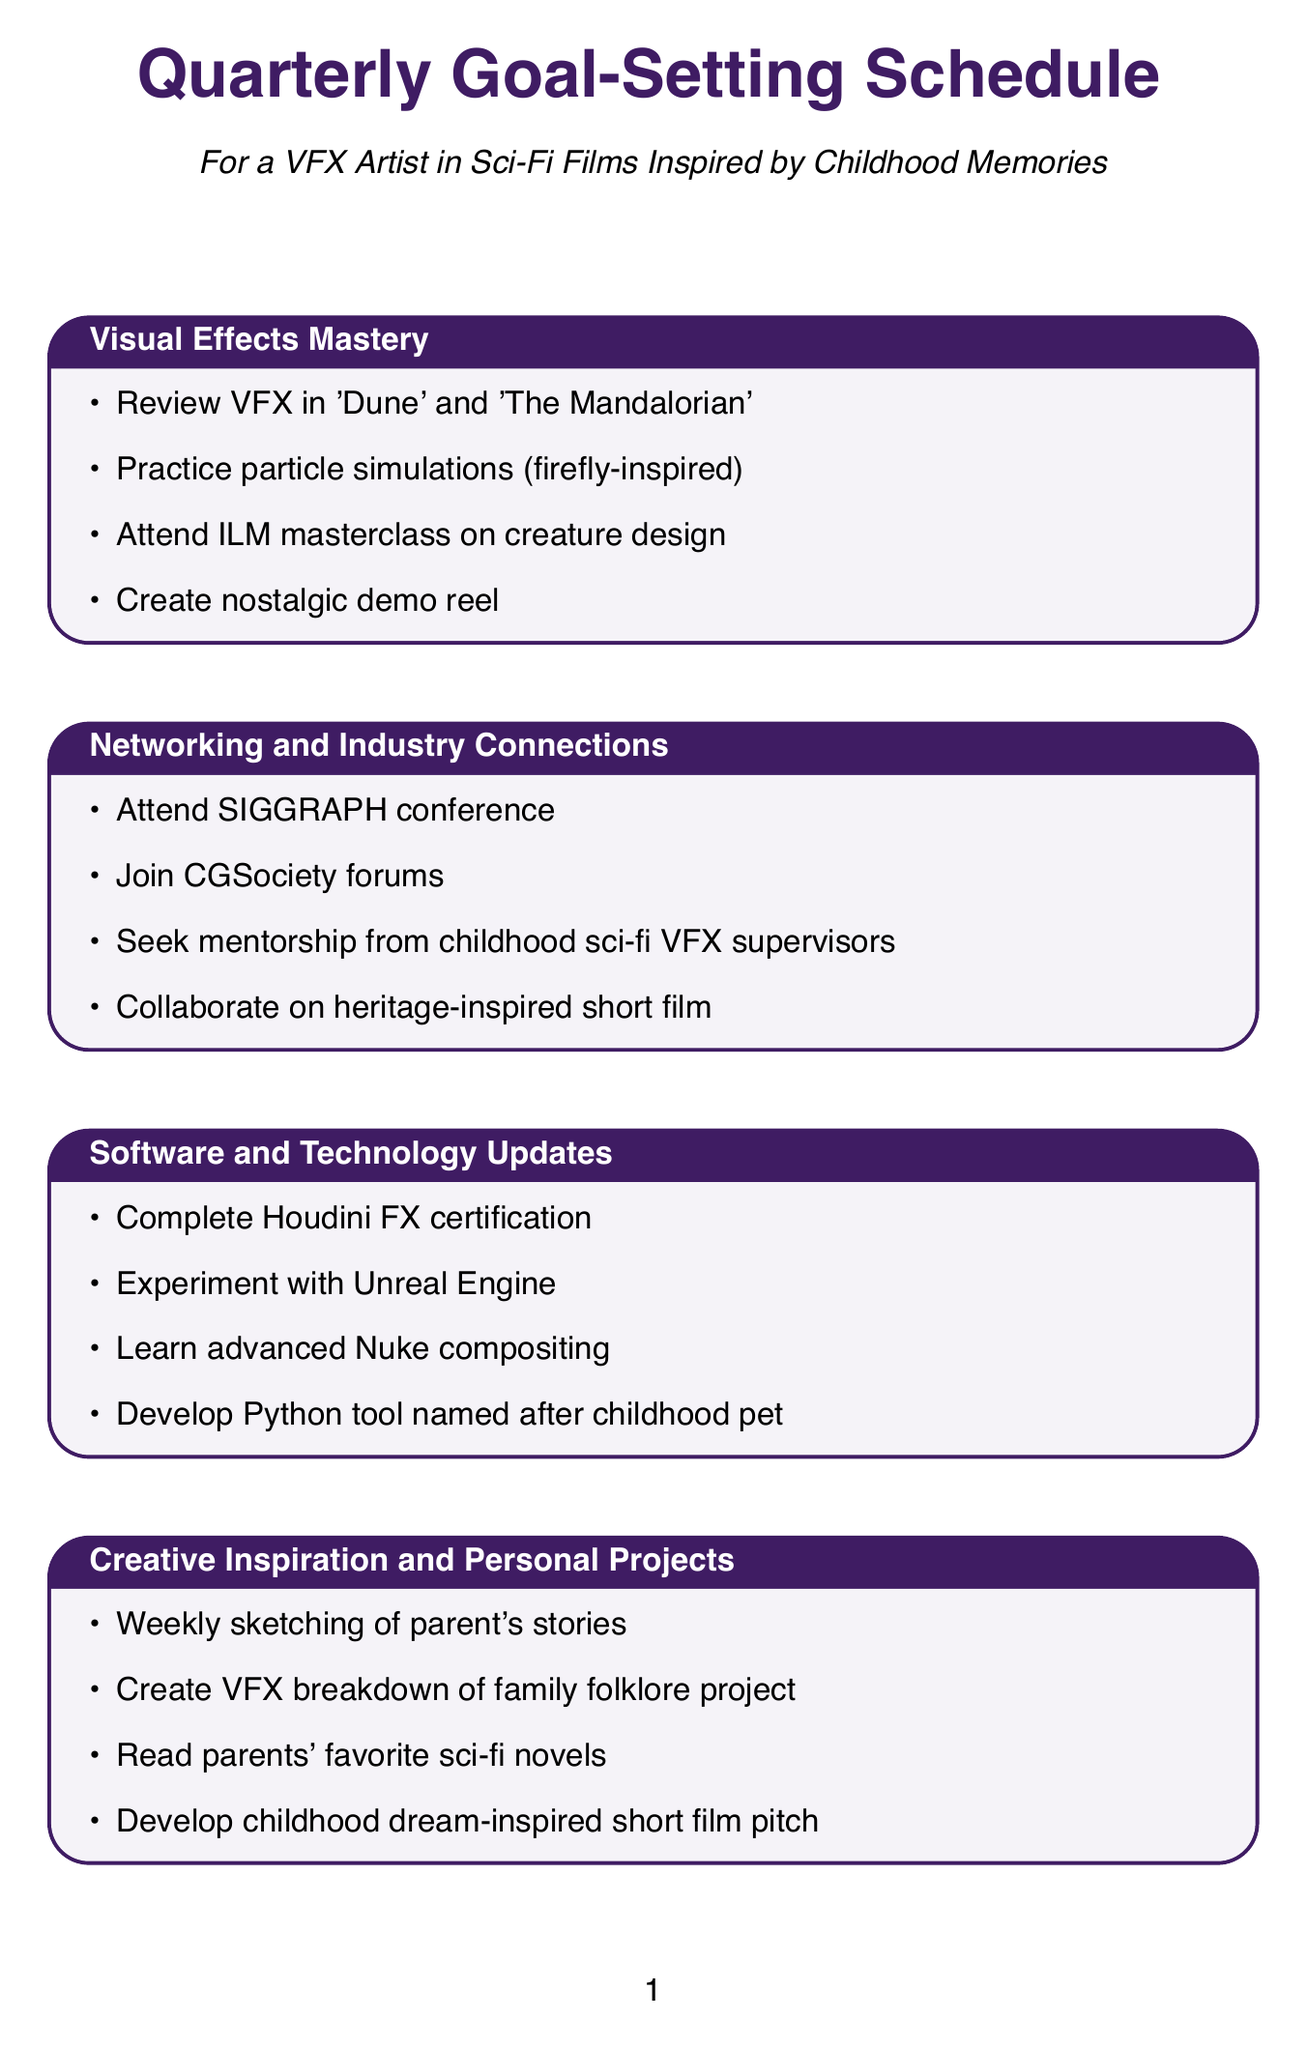What is the first session in the quarterly goal-setting schedule? The first session listed is "Visual Effects Mastery."
Answer: Visual Effects Mastery How many activities are listed under the "Creative Inspiration and Personal Projects" session? There are four activities mentioned in this session.
Answer: 4 Which software certification is included in the "Software and Technology Updates" session? The document states to complete "Houdini FX certification."
Answer: Houdini FX certification What unique theme is mentioned for the demo reel in the "Visual Effects Mastery" session? The demo reel should incorporate "nostalgic elements from family stories."
Answer: nostalgic elements from family stories What conference is recommended for networking in the "Networking and Industry Connections" session? The conference mentioned is "SIGGRAPH."
Answer: SIGGRAPH What is the purpose of the "five-year career plan" in the "Career Advancement Strategies" session? It is aimed at aligning goals with projects similar to favorite childhood films.
Answer: projects similar to favorite childhood films Which creature design masterclass is suggested in the "Visual Effects Mastery" session? The masterclass to attend is by "Industrial Light & Magic."
Answer: Industrial Light & Magic What activity involves sketching in the "Creative Inspiration and Personal Projects" session? The activity involves "drawing scenes from parent's stories."
Answer: drawing scenes from parent's stories 